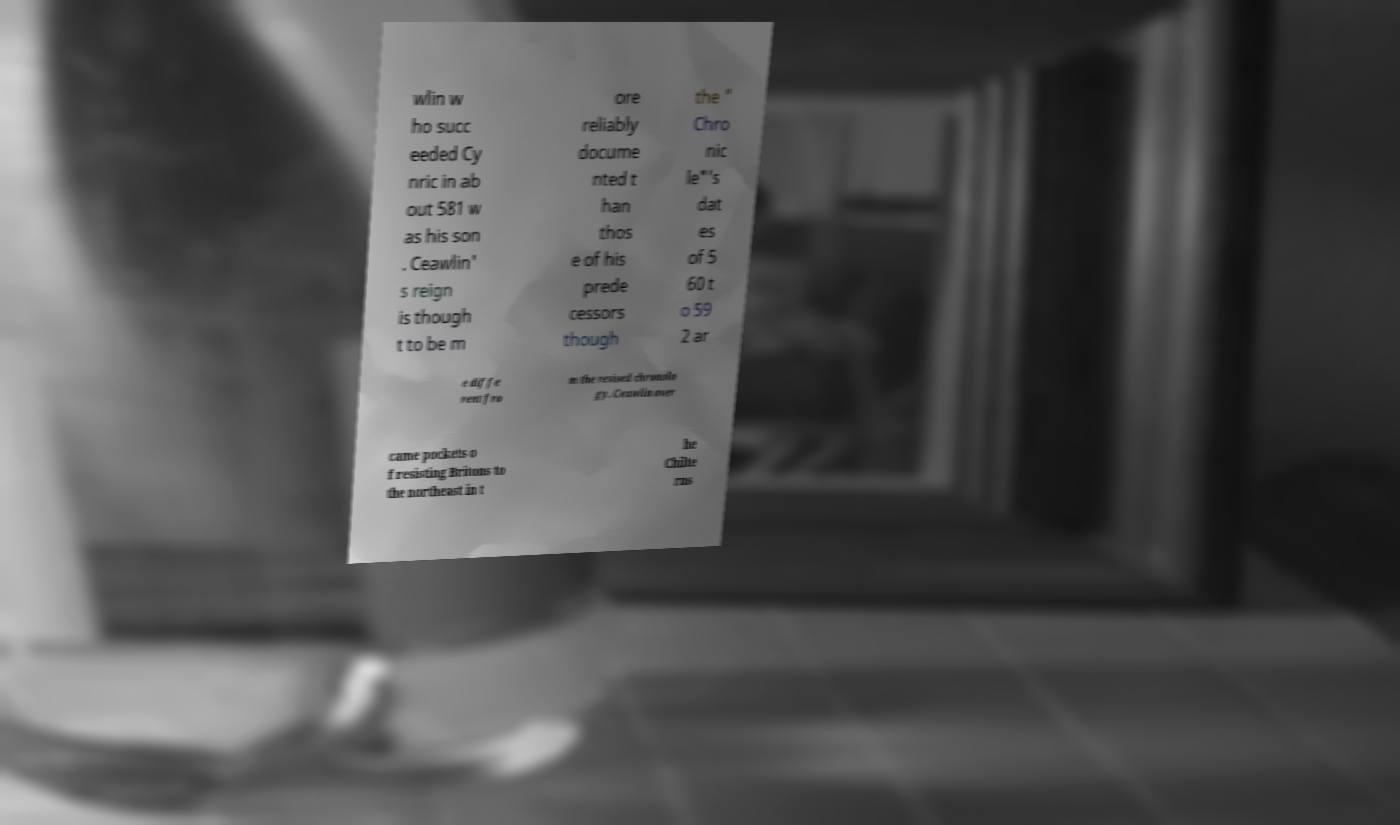I need the written content from this picture converted into text. Can you do that? wlin w ho succ eeded Cy nric in ab out 581 w as his son . Ceawlin' s reign is though t to be m ore reliably docume nted t han thos e of his prede cessors though the " Chro nic le"'s dat es of 5 60 t o 59 2 ar e diffe rent fro m the revised chronolo gy. Ceawlin over came pockets o f resisting Britons to the northeast in t he Chilte rns 